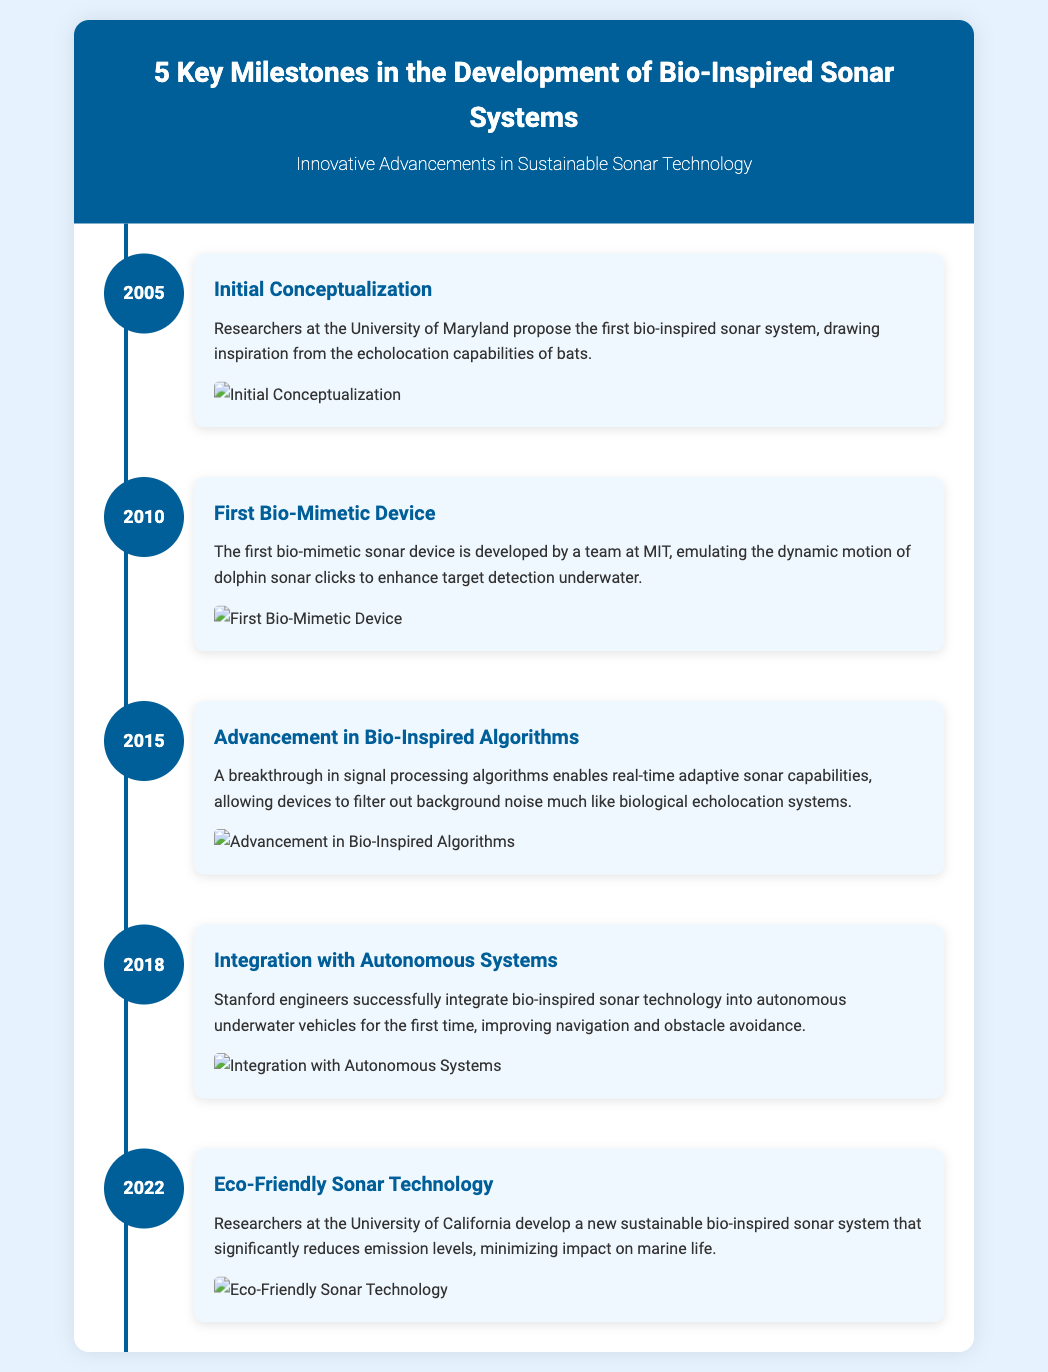What year was the initial conceptualization of bio-inspired sonar systems? The document states that the initial conceptualization took place in 2005.
Answer: 2005 Who developed the first bio-mimetic sonar device? The document credits a team at MIT for developing the first bio-mimetic sonar device.
Answer: MIT What is a key feature of the 2015 breakthrough in bio-inspired algorithms? The breakthrough allowed for real-time adaptive sonar capabilities to filter out background noise.
Answer: Real-time adaptive sonar capabilities Which institution integrated bio-inspired sonar technology into autonomous systems in 2018? The document indicates that Stanford engineers were responsible for this integration.
Answer: Stanford What was the primary achievement of researchers at the University of California in 2022? They developed a sustainable bio-inspired sonar system that reduces emission levels significantly.
Answer: Eco-friendly sonar technology What does the timeline infographic primarily focus on? The infographic centers on key milestones in the development of bio-inspired sonar systems.
Answer: Key milestones in bio-inspired sonar systems How many key milestones are highlighted in the document? The document lists a total of 5 key milestones.
Answer: 5 What animal's echolocation capabilities inspired the initial conceptualization of sonar systems? The initial conceptualization was inspired by the echolocation capabilities of bats.
Answer: Bats 